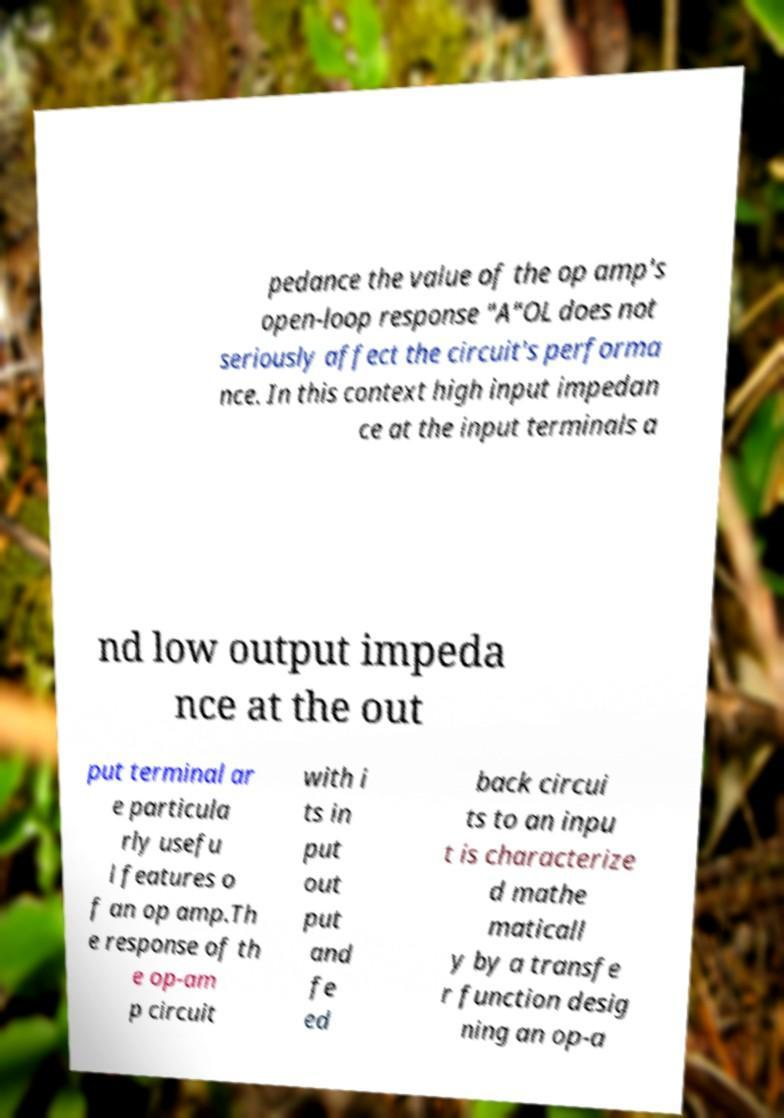Can you accurately transcribe the text from the provided image for me? pedance the value of the op amp's open-loop response "A"OL does not seriously affect the circuit's performa nce. In this context high input impedan ce at the input terminals a nd low output impeda nce at the out put terminal ar e particula rly usefu l features o f an op amp.Th e response of th e op-am p circuit with i ts in put out put and fe ed back circui ts to an inpu t is characterize d mathe maticall y by a transfe r function desig ning an op-a 